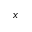<formula> <loc_0><loc_0><loc_500><loc_500>\ v x</formula> 